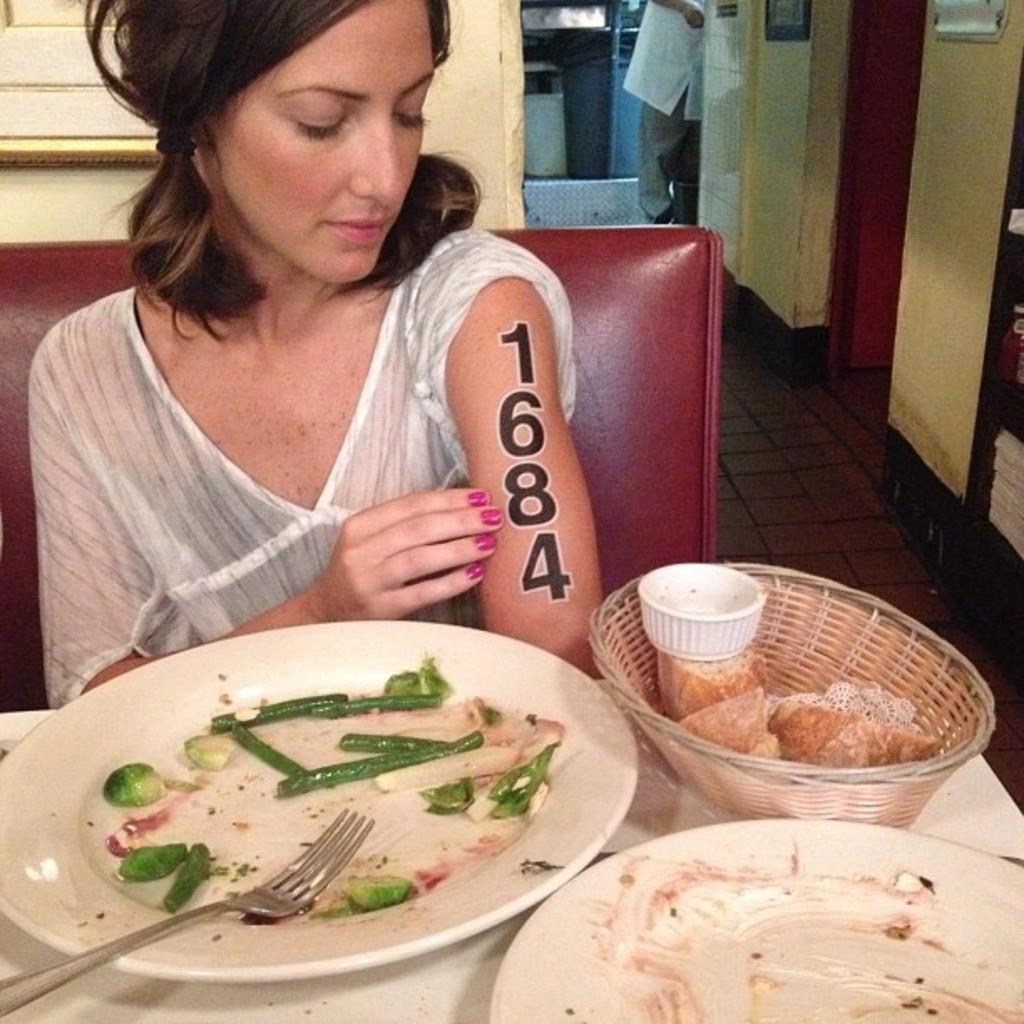How would you summarize this image in a sentence or two? In this picture we can see a woman sitting in front of a table, there are two plates and a basket present on the table, we can see a fork and some food in this plate, we can see another person in the background. 